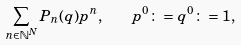Convert formula to latex. <formula><loc_0><loc_0><loc_500><loc_500>\sum _ { n \in \mathbb { N } ^ { N } } P _ { n } ( q ) p ^ { n } , \quad p ^ { 0 } \colon = q ^ { 0 } \colon = 1 ,</formula> 